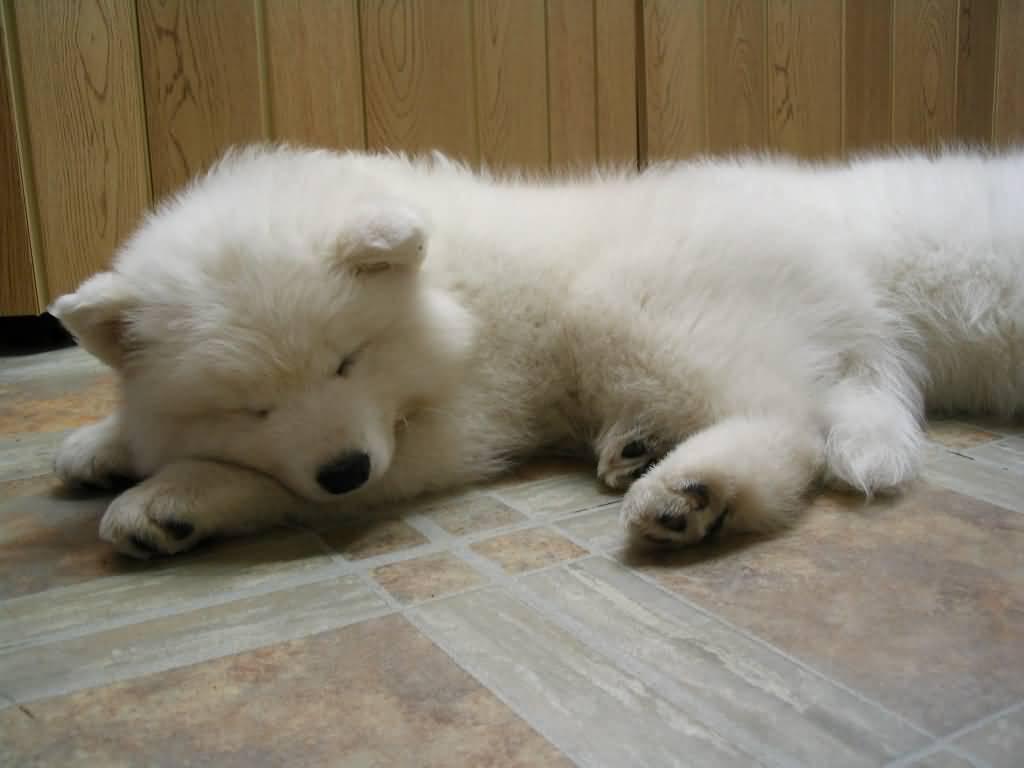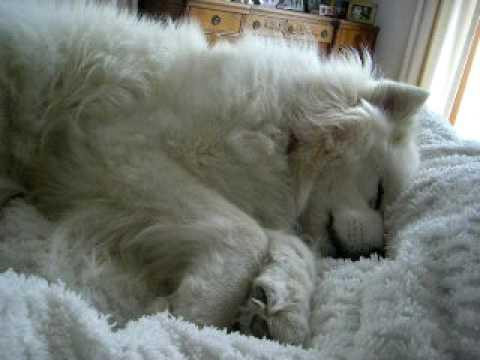The first image is the image on the left, the second image is the image on the right. Given the left and right images, does the statement "One image shows a white dog sleeping on a hard tile floor." hold true? Answer yes or no. Yes. 